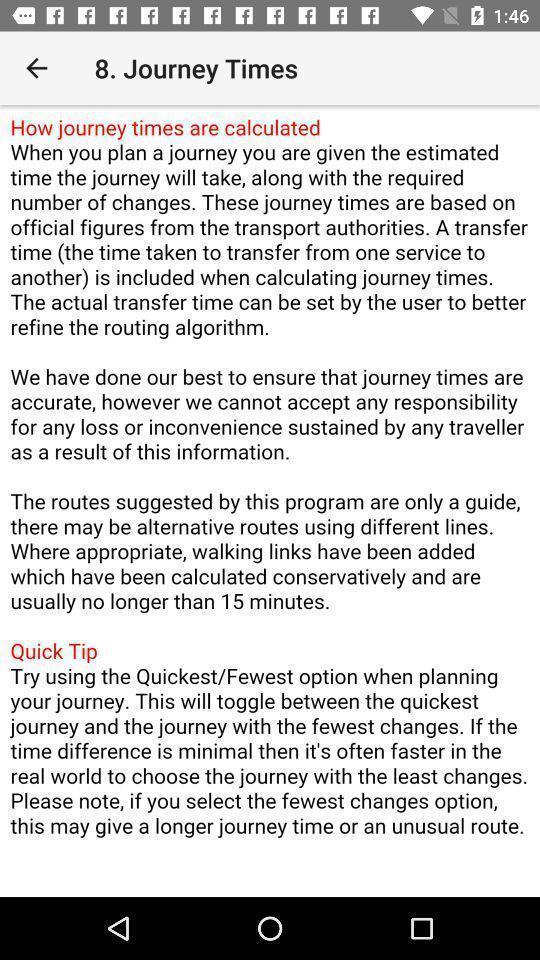Please provide a description for this image. Screen displaying the description and tips for journey times. 